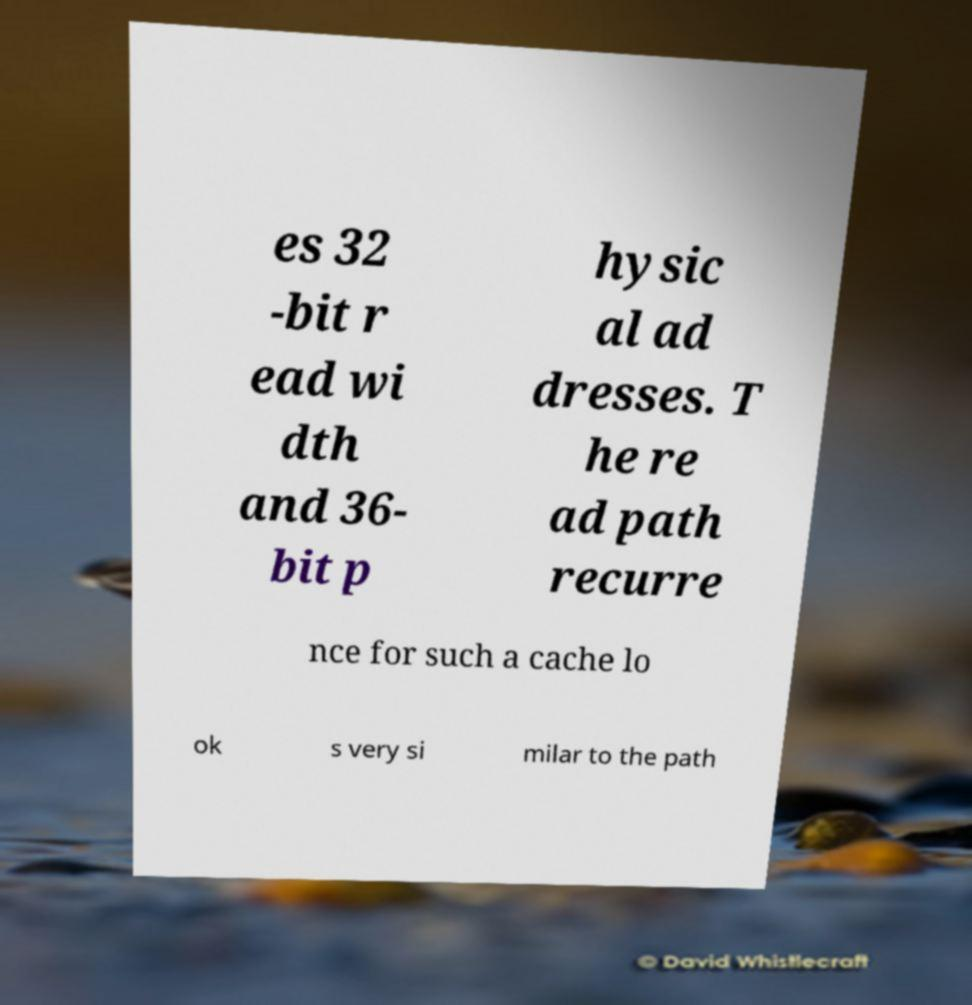I need the written content from this picture converted into text. Can you do that? es 32 -bit r ead wi dth and 36- bit p hysic al ad dresses. T he re ad path recurre nce for such a cache lo ok s very si milar to the path 